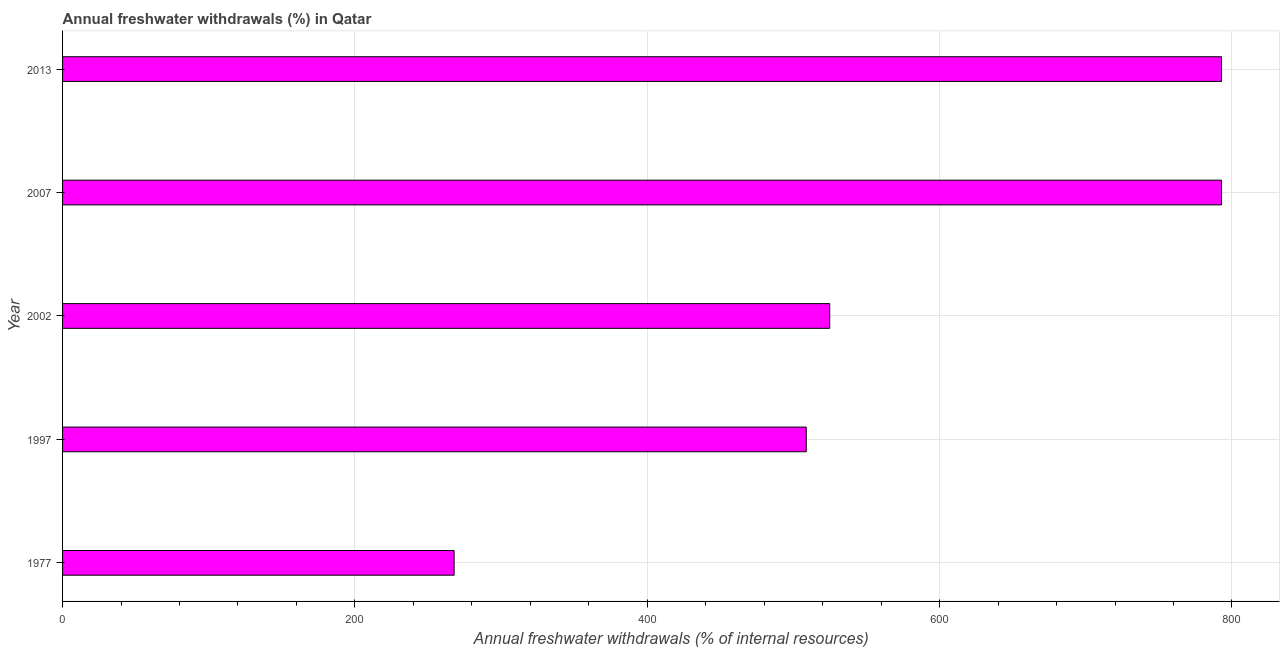Does the graph contain any zero values?
Ensure brevity in your answer.  No. What is the title of the graph?
Offer a terse response. Annual freshwater withdrawals (%) in Qatar. What is the label or title of the X-axis?
Keep it short and to the point. Annual freshwater withdrawals (% of internal resources). What is the label or title of the Y-axis?
Provide a short and direct response. Year. What is the annual freshwater withdrawals in 2002?
Offer a terse response. 524.82. Across all years, what is the maximum annual freshwater withdrawals?
Your answer should be compact. 792.86. Across all years, what is the minimum annual freshwater withdrawals?
Give a very brief answer. 267.86. In which year was the annual freshwater withdrawals maximum?
Your response must be concise. 2007. In which year was the annual freshwater withdrawals minimum?
Your response must be concise. 1977. What is the sum of the annual freshwater withdrawals?
Your answer should be compact. 2887.14. What is the difference between the annual freshwater withdrawals in 1997 and 2002?
Your answer should be very brief. -16.07. What is the average annual freshwater withdrawals per year?
Give a very brief answer. 577.43. What is the median annual freshwater withdrawals?
Your answer should be very brief. 524.82. Do a majority of the years between 1977 and 2013 (inclusive) have annual freshwater withdrawals greater than 80 %?
Your response must be concise. Yes. What is the ratio of the annual freshwater withdrawals in 1997 to that in 2007?
Your answer should be very brief. 0.64. Is the difference between the annual freshwater withdrawals in 2002 and 2007 greater than the difference between any two years?
Provide a short and direct response. No. Is the sum of the annual freshwater withdrawals in 1997 and 2007 greater than the maximum annual freshwater withdrawals across all years?
Give a very brief answer. Yes. What is the difference between the highest and the lowest annual freshwater withdrawals?
Your answer should be very brief. 525. How many bars are there?
Provide a succinct answer. 5. How many years are there in the graph?
Your answer should be compact. 5. Are the values on the major ticks of X-axis written in scientific E-notation?
Offer a very short reply. No. What is the Annual freshwater withdrawals (% of internal resources) of 1977?
Your answer should be compact. 267.86. What is the Annual freshwater withdrawals (% of internal resources) in 1997?
Ensure brevity in your answer.  508.75. What is the Annual freshwater withdrawals (% of internal resources) in 2002?
Make the answer very short. 524.82. What is the Annual freshwater withdrawals (% of internal resources) in 2007?
Your answer should be very brief. 792.86. What is the Annual freshwater withdrawals (% of internal resources) in 2013?
Offer a terse response. 792.86. What is the difference between the Annual freshwater withdrawals (% of internal resources) in 1977 and 1997?
Give a very brief answer. -240.89. What is the difference between the Annual freshwater withdrawals (% of internal resources) in 1977 and 2002?
Offer a very short reply. -256.96. What is the difference between the Annual freshwater withdrawals (% of internal resources) in 1977 and 2007?
Your answer should be compact. -525. What is the difference between the Annual freshwater withdrawals (% of internal resources) in 1977 and 2013?
Provide a succinct answer. -525. What is the difference between the Annual freshwater withdrawals (% of internal resources) in 1997 and 2002?
Offer a very short reply. -16.07. What is the difference between the Annual freshwater withdrawals (% of internal resources) in 1997 and 2007?
Provide a short and direct response. -284.11. What is the difference between the Annual freshwater withdrawals (% of internal resources) in 1997 and 2013?
Make the answer very short. -284.11. What is the difference between the Annual freshwater withdrawals (% of internal resources) in 2002 and 2007?
Your answer should be very brief. -268.04. What is the difference between the Annual freshwater withdrawals (% of internal resources) in 2002 and 2013?
Ensure brevity in your answer.  -268.04. What is the difference between the Annual freshwater withdrawals (% of internal resources) in 2007 and 2013?
Your answer should be very brief. 0. What is the ratio of the Annual freshwater withdrawals (% of internal resources) in 1977 to that in 1997?
Your answer should be compact. 0.53. What is the ratio of the Annual freshwater withdrawals (% of internal resources) in 1977 to that in 2002?
Your response must be concise. 0.51. What is the ratio of the Annual freshwater withdrawals (% of internal resources) in 1977 to that in 2007?
Ensure brevity in your answer.  0.34. What is the ratio of the Annual freshwater withdrawals (% of internal resources) in 1977 to that in 2013?
Provide a short and direct response. 0.34. What is the ratio of the Annual freshwater withdrawals (% of internal resources) in 1997 to that in 2007?
Provide a succinct answer. 0.64. What is the ratio of the Annual freshwater withdrawals (% of internal resources) in 1997 to that in 2013?
Make the answer very short. 0.64. What is the ratio of the Annual freshwater withdrawals (% of internal resources) in 2002 to that in 2007?
Give a very brief answer. 0.66. What is the ratio of the Annual freshwater withdrawals (% of internal resources) in 2002 to that in 2013?
Your answer should be very brief. 0.66. What is the ratio of the Annual freshwater withdrawals (% of internal resources) in 2007 to that in 2013?
Your answer should be compact. 1. 